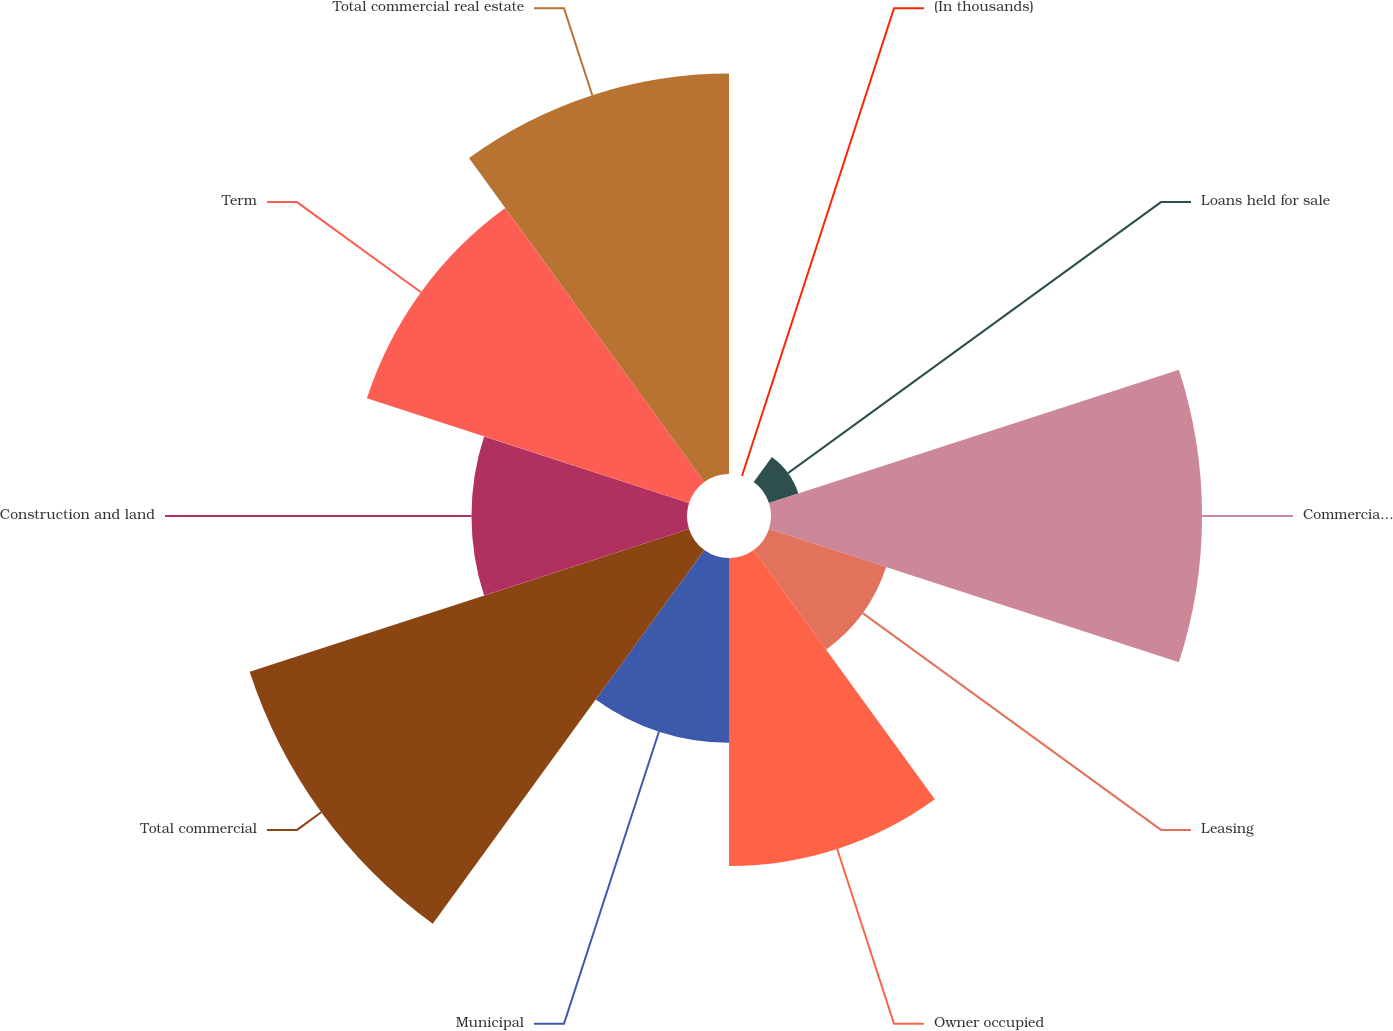Convert chart to OTSL. <chart><loc_0><loc_0><loc_500><loc_500><pie_chart><fcel>(In thousands)<fcel>Loans held for sale<fcel>Commercial and industrial<fcel>Leasing<fcel>Owner occupied<fcel>Municipal<fcel>Total commercial<fcel>Construction and land<fcel>Term<fcel>Total commercial real estate<nl><fcel>0.0%<fcel>1.24%<fcel>17.28%<fcel>4.94%<fcel>12.35%<fcel>7.41%<fcel>18.52%<fcel>8.64%<fcel>13.58%<fcel>16.05%<nl></chart> 